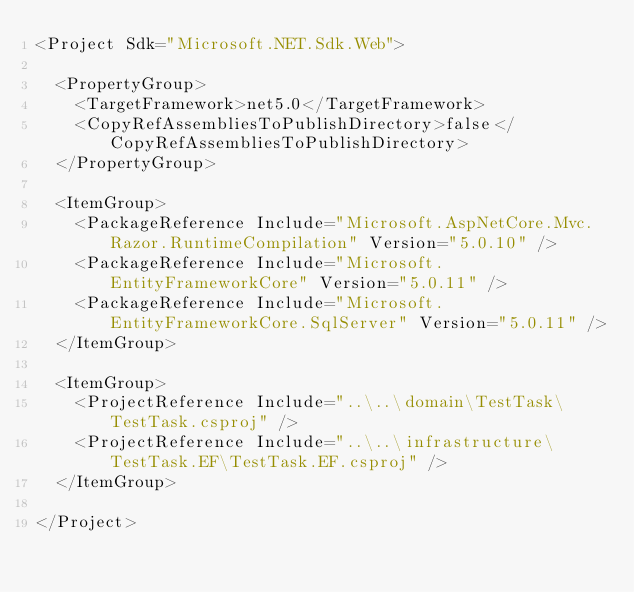Convert code to text. <code><loc_0><loc_0><loc_500><loc_500><_XML_><Project Sdk="Microsoft.NET.Sdk.Web">

  <PropertyGroup>
    <TargetFramework>net5.0</TargetFramework>
    <CopyRefAssembliesToPublishDirectory>false</CopyRefAssembliesToPublishDirectory>
  </PropertyGroup>

  <ItemGroup>
    <PackageReference Include="Microsoft.AspNetCore.Mvc.Razor.RuntimeCompilation" Version="5.0.10" />
    <PackageReference Include="Microsoft.EntityFrameworkCore" Version="5.0.11" />
    <PackageReference Include="Microsoft.EntityFrameworkCore.SqlServer" Version="5.0.11" />
  </ItemGroup>

  <ItemGroup>
    <ProjectReference Include="..\..\domain\TestTask\TestTask.csproj" />
    <ProjectReference Include="..\..\infrastructure\TestTask.EF\TestTask.EF.csproj" />
  </ItemGroup>

</Project>
</code> 